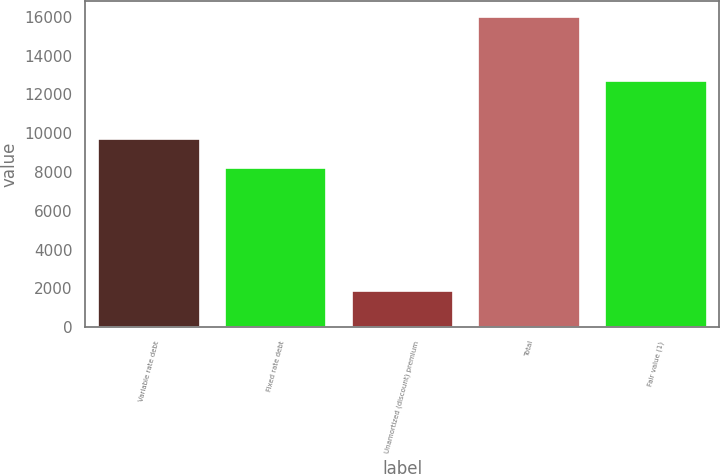Convert chart. <chart><loc_0><loc_0><loc_500><loc_500><bar_chart><fcel>Variable rate debt<fcel>Fixed rate debt<fcel>Unamortized (discount) premium<fcel>Total<fcel>Fair value (1)<nl><fcel>9678<fcel>8187<fcel>1859<fcel>16006<fcel>12695<nl></chart> 